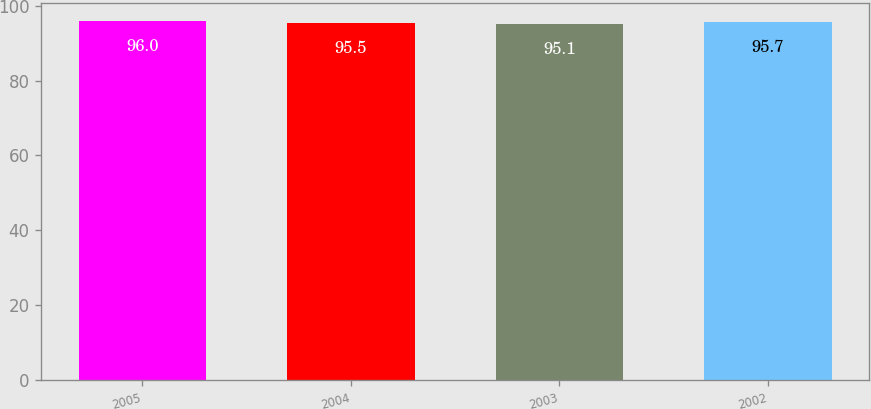Convert chart. <chart><loc_0><loc_0><loc_500><loc_500><bar_chart><fcel>2005<fcel>2004<fcel>2003<fcel>2002<nl><fcel>96<fcel>95.5<fcel>95.1<fcel>95.7<nl></chart> 